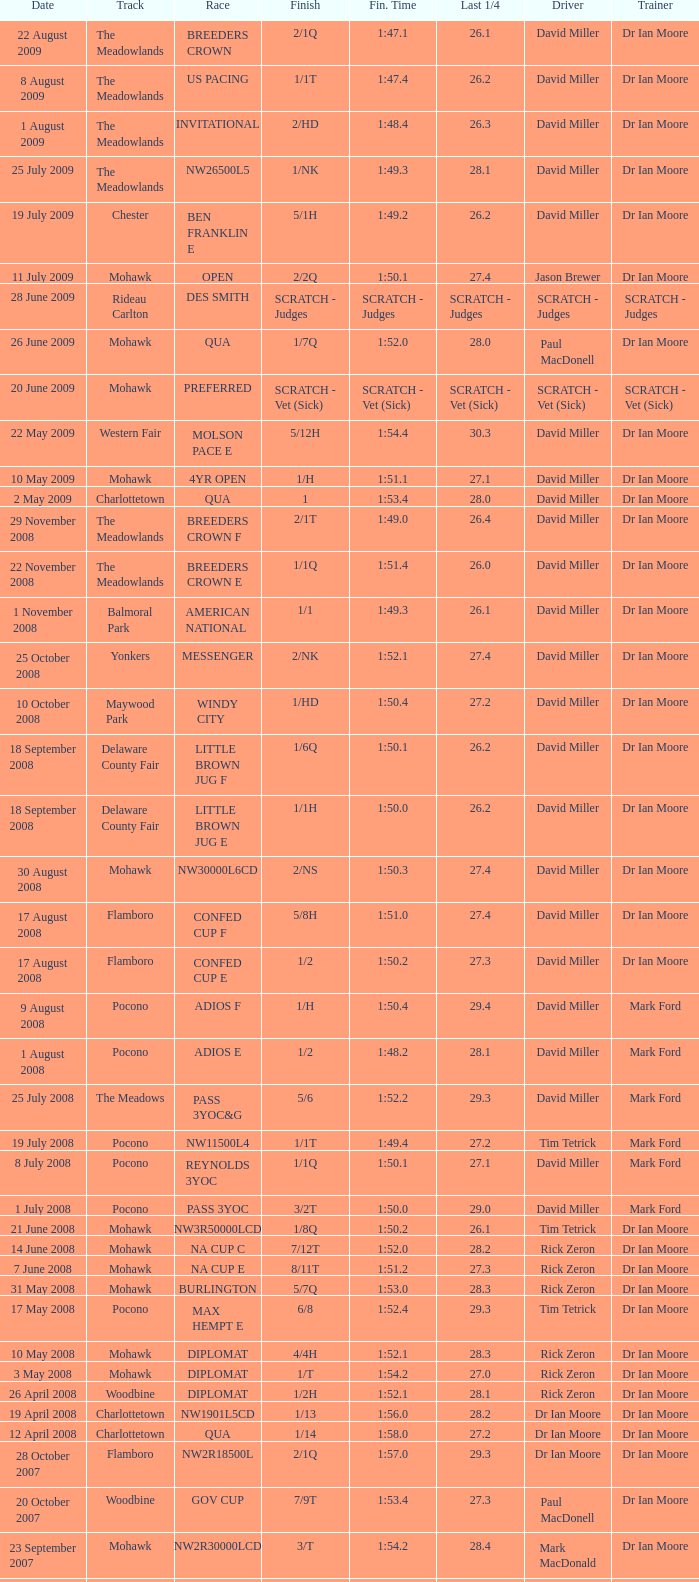What is the time for the last 1/4 of the qua race that ends in 2:03.1? 29.2. 